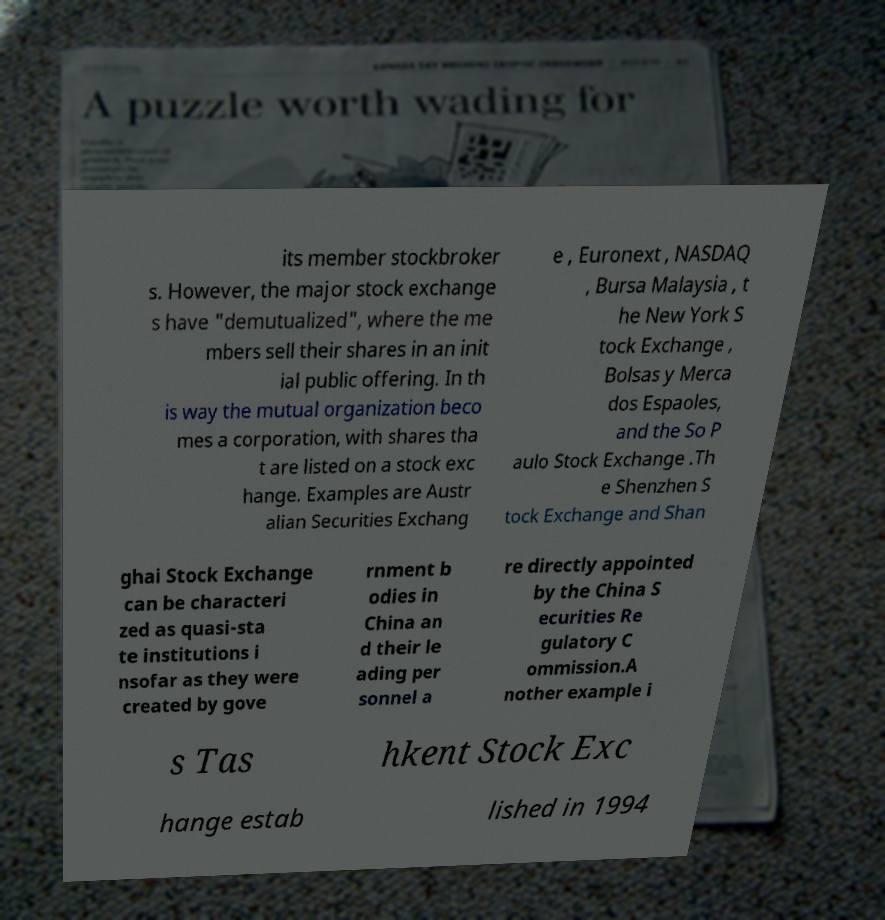Can you read and provide the text displayed in the image?This photo seems to have some interesting text. Can you extract and type it out for me? its member stockbroker s. However, the major stock exchange s have "demutualized", where the me mbers sell their shares in an init ial public offering. In th is way the mutual organization beco mes a corporation, with shares tha t are listed on a stock exc hange. Examples are Austr alian Securities Exchang e , Euronext , NASDAQ , Bursa Malaysia , t he New York S tock Exchange , Bolsas y Merca dos Espaoles, and the So P aulo Stock Exchange .Th e Shenzhen S tock Exchange and Shan ghai Stock Exchange can be characteri zed as quasi-sta te institutions i nsofar as they were created by gove rnment b odies in China an d their le ading per sonnel a re directly appointed by the China S ecurities Re gulatory C ommission.A nother example i s Tas hkent Stock Exc hange estab lished in 1994 